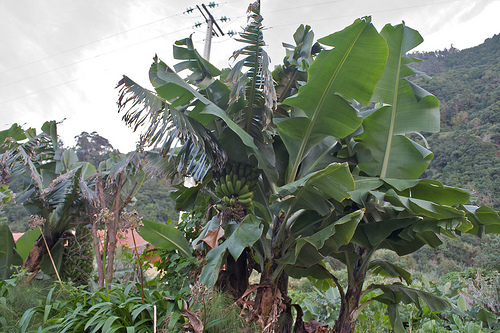<image>
Is there a banana tree behind the mountain? No. The banana tree is not behind the mountain. From this viewpoint, the banana tree appears to be positioned elsewhere in the scene. 